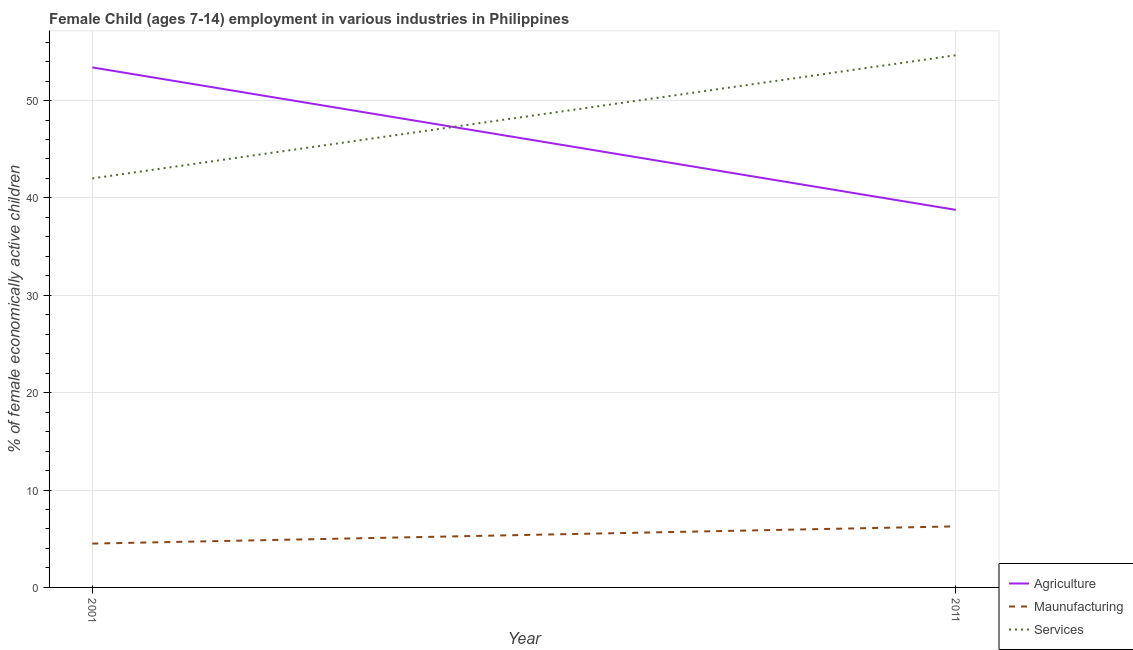How many different coloured lines are there?
Give a very brief answer. 3. Does the line corresponding to percentage of economically active children in manufacturing intersect with the line corresponding to percentage of economically active children in services?
Provide a succinct answer. No. Is the number of lines equal to the number of legend labels?
Keep it short and to the point. Yes. What is the percentage of economically active children in manufacturing in 2011?
Ensure brevity in your answer.  6.27. Across all years, what is the maximum percentage of economically active children in agriculture?
Your answer should be compact. 53.4. Across all years, what is the minimum percentage of economically active children in agriculture?
Provide a short and direct response. 38.77. In which year was the percentage of economically active children in services minimum?
Ensure brevity in your answer.  2001. What is the total percentage of economically active children in manufacturing in the graph?
Your response must be concise. 10.77. What is the difference between the percentage of economically active children in agriculture in 2001 and that in 2011?
Provide a short and direct response. 14.63. What is the difference between the percentage of economically active children in agriculture in 2011 and the percentage of economically active children in manufacturing in 2001?
Provide a short and direct response. 34.27. What is the average percentage of economically active children in agriculture per year?
Keep it short and to the point. 46.09. In the year 2001, what is the difference between the percentage of economically active children in services and percentage of economically active children in manufacturing?
Offer a terse response. 37.5. What is the ratio of the percentage of economically active children in manufacturing in 2001 to that in 2011?
Your response must be concise. 0.72. Is the percentage of economically active children in agriculture in 2001 less than that in 2011?
Your answer should be very brief. No. Is it the case that in every year, the sum of the percentage of economically active children in agriculture and percentage of economically active children in manufacturing is greater than the percentage of economically active children in services?
Keep it short and to the point. No. Does the percentage of economically active children in services monotonically increase over the years?
Make the answer very short. Yes. Is the percentage of economically active children in services strictly greater than the percentage of economically active children in agriculture over the years?
Make the answer very short. No. Is the percentage of economically active children in services strictly less than the percentage of economically active children in agriculture over the years?
Provide a succinct answer. No. How many lines are there?
Provide a succinct answer. 3. How many years are there in the graph?
Offer a very short reply. 2. What is the difference between two consecutive major ticks on the Y-axis?
Your answer should be very brief. 10. Does the graph contain any zero values?
Your answer should be compact. No. How are the legend labels stacked?
Your answer should be very brief. Vertical. What is the title of the graph?
Provide a short and direct response. Female Child (ages 7-14) employment in various industries in Philippines. What is the label or title of the Y-axis?
Provide a succinct answer. % of female economically active children. What is the % of female economically active children of Agriculture in 2001?
Ensure brevity in your answer.  53.4. What is the % of female economically active children in Services in 2001?
Provide a succinct answer. 42. What is the % of female economically active children of Agriculture in 2011?
Keep it short and to the point. 38.77. What is the % of female economically active children in Maunufacturing in 2011?
Ensure brevity in your answer.  6.27. What is the % of female economically active children of Services in 2011?
Your answer should be very brief. 54.65. Across all years, what is the maximum % of female economically active children of Agriculture?
Provide a succinct answer. 53.4. Across all years, what is the maximum % of female economically active children in Maunufacturing?
Offer a terse response. 6.27. Across all years, what is the maximum % of female economically active children in Services?
Your answer should be compact. 54.65. Across all years, what is the minimum % of female economically active children of Agriculture?
Your answer should be compact. 38.77. Across all years, what is the minimum % of female economically active children in Maunufacturing?
Give a very brief answer. 4.5. What is the total % of female economically active children in Agriculture in the graph?
Offer a very short reply. 92.17. What is the total % of female economically active children of Maunufacturing in the graph?
Offer a terse response. 10.77. What is the total % of female economically active children of Services in the graph?
Your answer should be compact. 96.65. What is the difference between the % of female economically active children of Agriculture in 2001 and that in 2011?
Your answer should be very brief. 14.63. What is the difference between the % of female economically active children of Maunufacturing in 2001 and that in 2011?
Offer a very short reply. -1.77. What is the difference between the % of female economically active children of Services in 2001 and that in 2011?
Give a very brief answer. -12.65. What is the difference between the % of female economically active children of Agriculture in 2001 and the % of female economically active children of Maunufacturing in 2011?
Your answer should be compact. 47.13. What is the difference between the % of female economically active children of Agriculture in 2001 and the % of female economically active children of Services in 2011?
Ensure brevity in your answer.  -1.25. What is the difference between the % of female economically active children of Maunufacturing in 2001 and the % of female economically active children of Services in 2011?
Provide a succinct answer. -50.15. What is the average % of female economically active children in Agriculture per year?
Your answer should be very brief. 46.09. What is the average % of female economically active children of Maunufacturing per year?
Provide a succinct answer. 5.38. What is the average % of female economically active children of Services per year?
Provide a short and direct response. 48.33. In the year 2001, what is the difference between the % of female economically active children in Agriculture and % of female economically active children in Maunufacturing?
Provide a succinct answer. 48.9. In the year 2001, what is the difference between the % of female economically active children in Agriculture and % of female economically active children in Services?
Provide a short and direct response. 11.4. In the year 2001, what is the difference between the % of female economically active children in Maunufacturing and % of female economically active children in Services?
Your answer should be compact. -37.5. In the year 2011, what is the difference between the % of female economically active children in Agriculture and % of female economically active children in Maunufacturing?
Your answer should be compact. 32.5. In the year 2011, what is the difference between the % of female economically active children of Agriculture and % of female economically active children of Services?
Provide a short and direct response. -15.88. In the year 2011, what is the difference between the % of female economically active children of Maunufacturing and % of female economically active children of Services?
Your response must be concise. -48.38. What is the ratio of the % of female economically active children in Agriculture in 2001 to that in 2011?
Keep it short and to the point. 1.38. What is the ratio of the % of female economically active children in Maunufacturing in 2001 to that in 2011?
Offer a very short reply. 0.72. What is the ratio of the % of female economically active children in Services in 2001 to that in 2011?
Make the answer very short. 0.77. What is the difference between the highest and the second highest % of female economically active children in Agriculture?
Your response must be concise. 14.63. What is the difference between the highest and the second highest % of female economically active children of Maunufacturing?
Ensure brevity in your answer.  1.77. What is the difference between the highest and the second highest % of female economically active children of Services?
Ensure brevity in your answer.  12.65. What is the difference between the highest and the lowest % of female economically active children of Agriculture?
Your response must be concise. 14.63. What is the difference between the highest and the lowest % of female economically active children of Maunufacturing?
Give a very brief answer. 1.77. What is the difference between the highest and the lowest % of female economically active children in Services?
Keep it short and to the point. 12.65. 